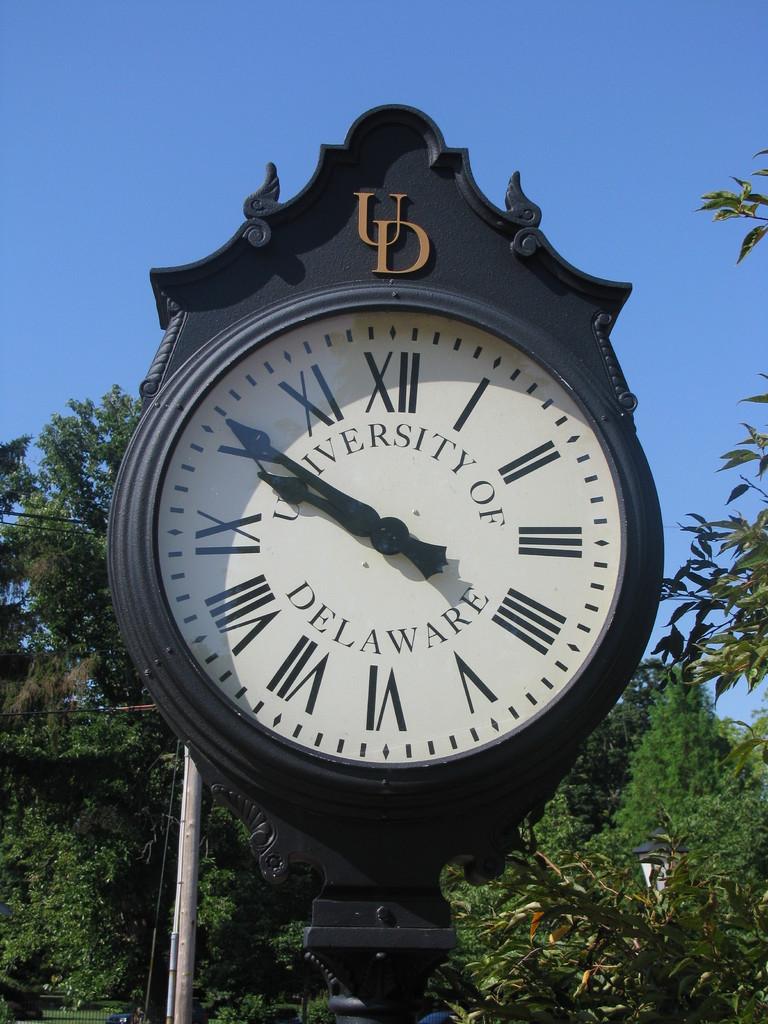What university is this clock affiliated with?
Your answer should be compact. University of delaware. What letter are in black above the clock face?
Give a very brief answer. Ud. 